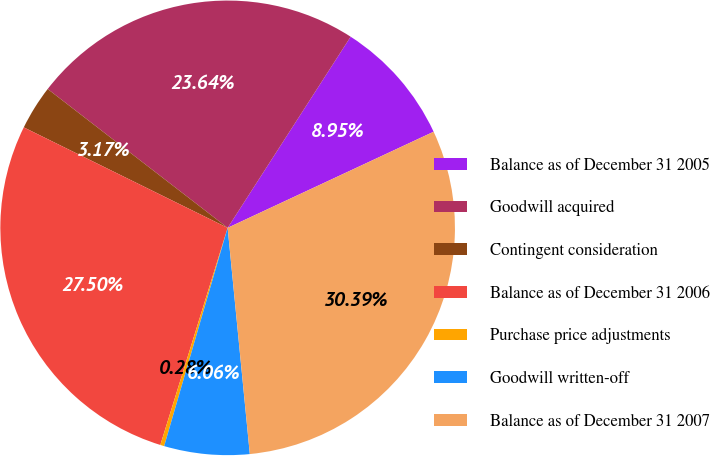Convert chart. <chart><loc_0><loc_0><loc_500><loc_500><pie_chart><fcel>Balance as of December 31 2005<fcel>Goodwill acquired<fcel>Contingent consideration<fcel>Balance as of December 31 2006<fcel>Purchase price adjustments<fcel>Goodwill written-off<fcel>Balance as of December 31 2007<nl><fcel>8.95%<fcel>23.64%<fcel>3.17%<fcel>27.5%<fcel>0.28%<fcel>6.06%<fcel>30.39%<nl></chart> 